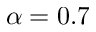Convert formula to latex. <formula><loc_0><loc_0><loc_500><loc_500>\alpha = 0 . 7</formula> 